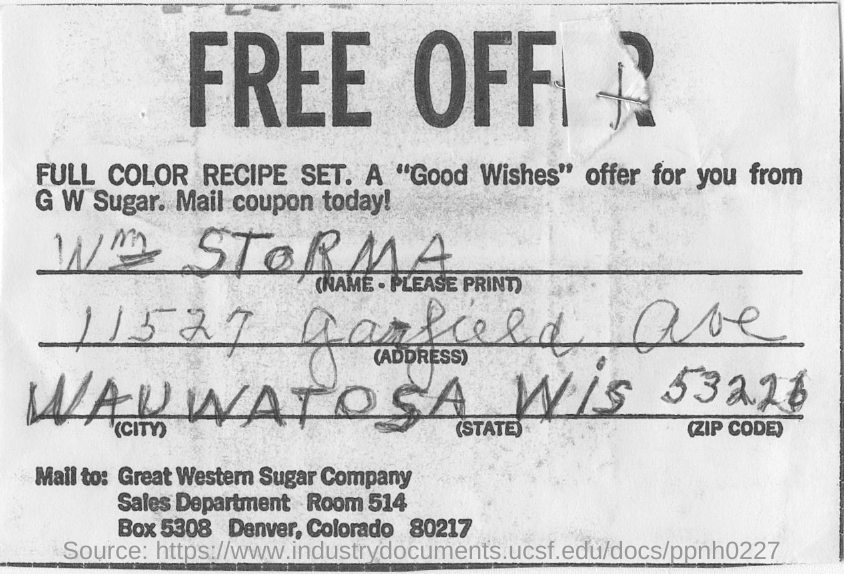Mention a couple of crucial points in this snapshot. The zip code is 53226. Wauwatosa is the city where W STORMA resides. 